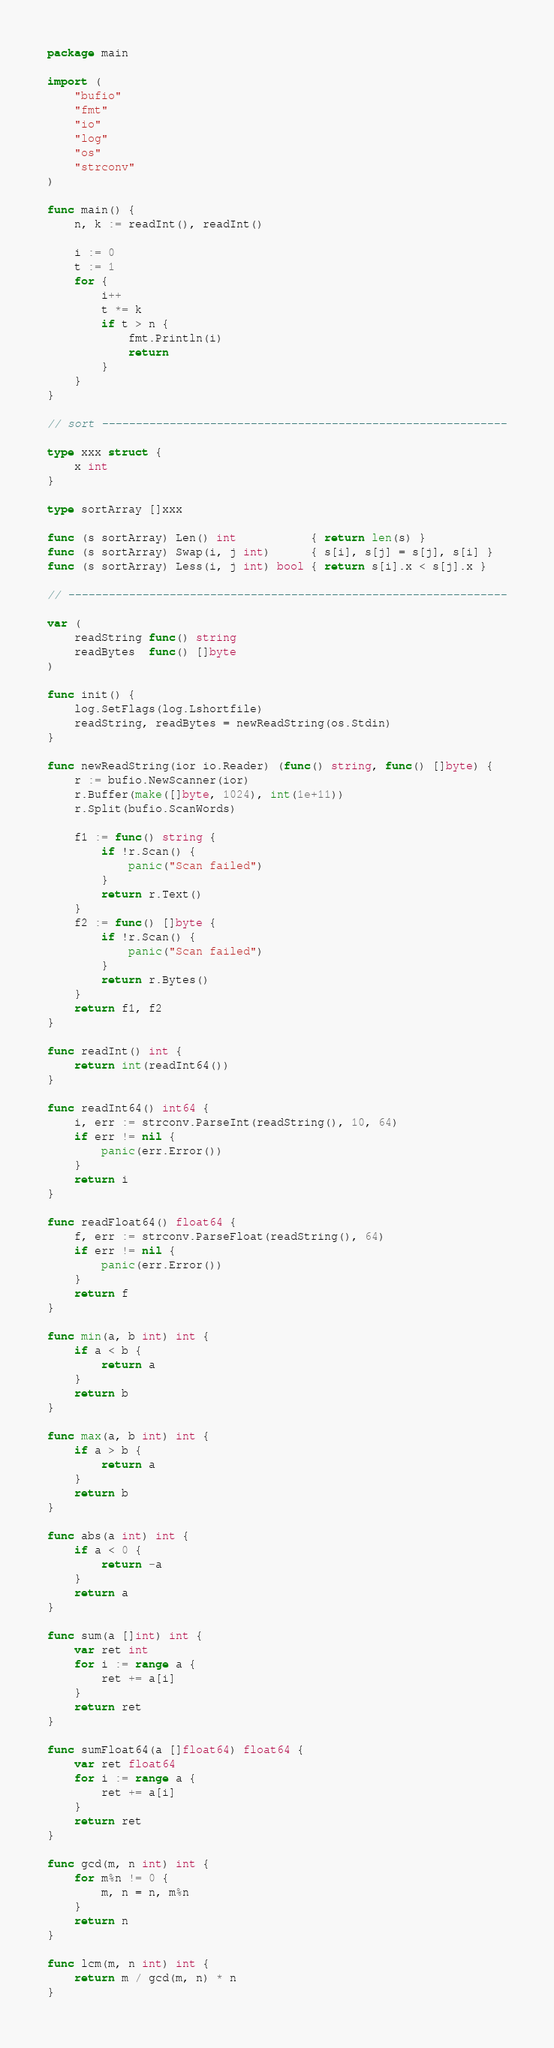<code> <loc_0><loc_0><loc_500><loc_500><_Go_>package main

import (
	"bufio"
	"fmt"
	"io"
	"log"
	"os"
	"strconv"
)

func main() {
	n, k := readInt(), readInt()

	i := 0
	t := 1
	for {
		i++
		t *= k
		if t > n {
			fmt.Println(i)
			return
		}
	}
}

// sort ------------------------------------------------------------

type xxx struct {
	x int
}

type sortArray []xxx

func (s sortArray) Len() int           { return len(s) }
func (s sortArray) Swap(i, j int)      { s[i], s[j] = s[j], s[i] }
func (s sortArray) Less(i, j int) bool { return s[i].x < s[j].x }

// -----------------------------------------------------------------

var (
	readString func() string
	readBytes  func() []byte
)

func init() {
	log.SetFlags(log.Lshortfile)
	readString, readBytes = newReadString(os.Stdin)
}

func newReadString(ior io.Reader) (func() string, func() []byte) {
	r := bufio.NewScanner(ior)
	r.Buffer(make([]byte, 1024), int(1e+11))
	r.Split(bufio.ScanWords)

	f1 := func() string {
		if !r.Scan() {
			panic("Scan failed")
		}
		return r.Text()
	}
	f2 := func() []byte {
		if !r.Scan() {
			panic("Scan failed")
		}
		return r.Bytes()
	}
	return f1, f2
}

func readInt() int {
	return int(readInt64())
}

func readInt64() int64 {
	i, err := strconv.ParseInt(readString(), 10, 64)
	if err != nil {
		panic(err.Error())
	}
	return i
}

func readFloat64() float64 {
	f, err := strconv.ParseFloat(readString(), 64)
	if err != nil {
		panic(err.Error())
	}
	return f
}

func min(a, b int) int {
	if a < b {
		return a
	}
	return b
}

func max(a, b int) int {
	if a > b {
		return a
	}
	return b
}

func abs(a int) int {
	if a < 0 {
		return -a
	}
	return a
}

func sum(a []int) int {
	var ret int
	for i := range a {
		ret += a[i]
	}
	return ret
}

func sumFloat64(a []float64) float64 {
	var ret float64
	for i := range a {
		ret += a[i]
	}
	return ret
}

func gcd(m, n int) int {
	for m%n != 0 {
		m, n = n, m%n
	}
	return n
}

func lcm(m, n int) int {
	return m / gcd(m, n) * n
}
</code> 